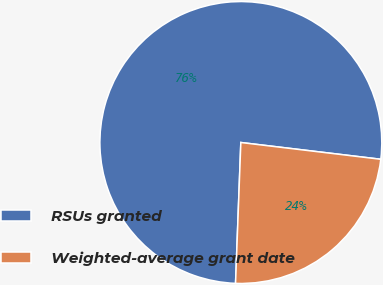<chart> <loc_0><loc_0><loc_500><loc_500><pie_chart><fcel>RSUs granted<fcel>Weighted-average grant date<nl><fcel>76.3%<fcel>23.7%<nl></chart> 